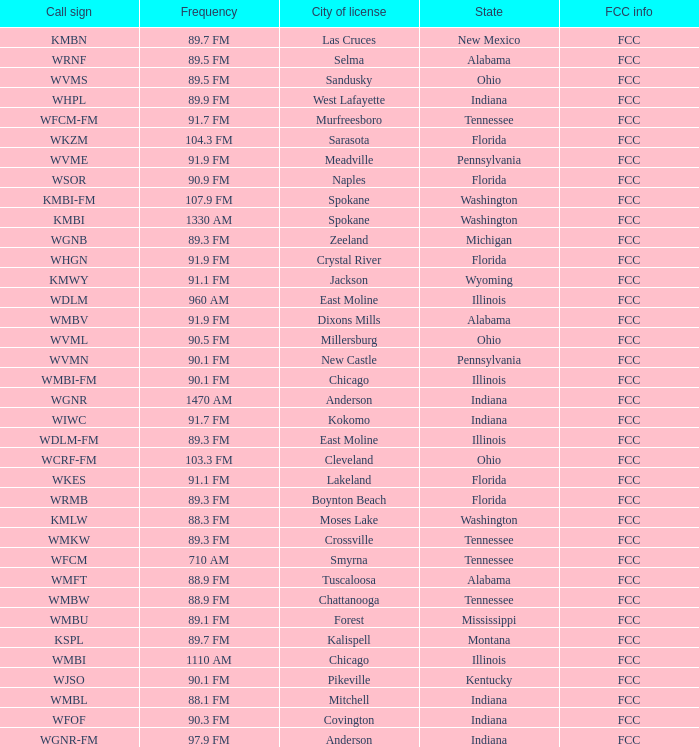What state is the radio station in that has a frequency of 90.1 FM and a city license in New Castle? Pennsylvania. 